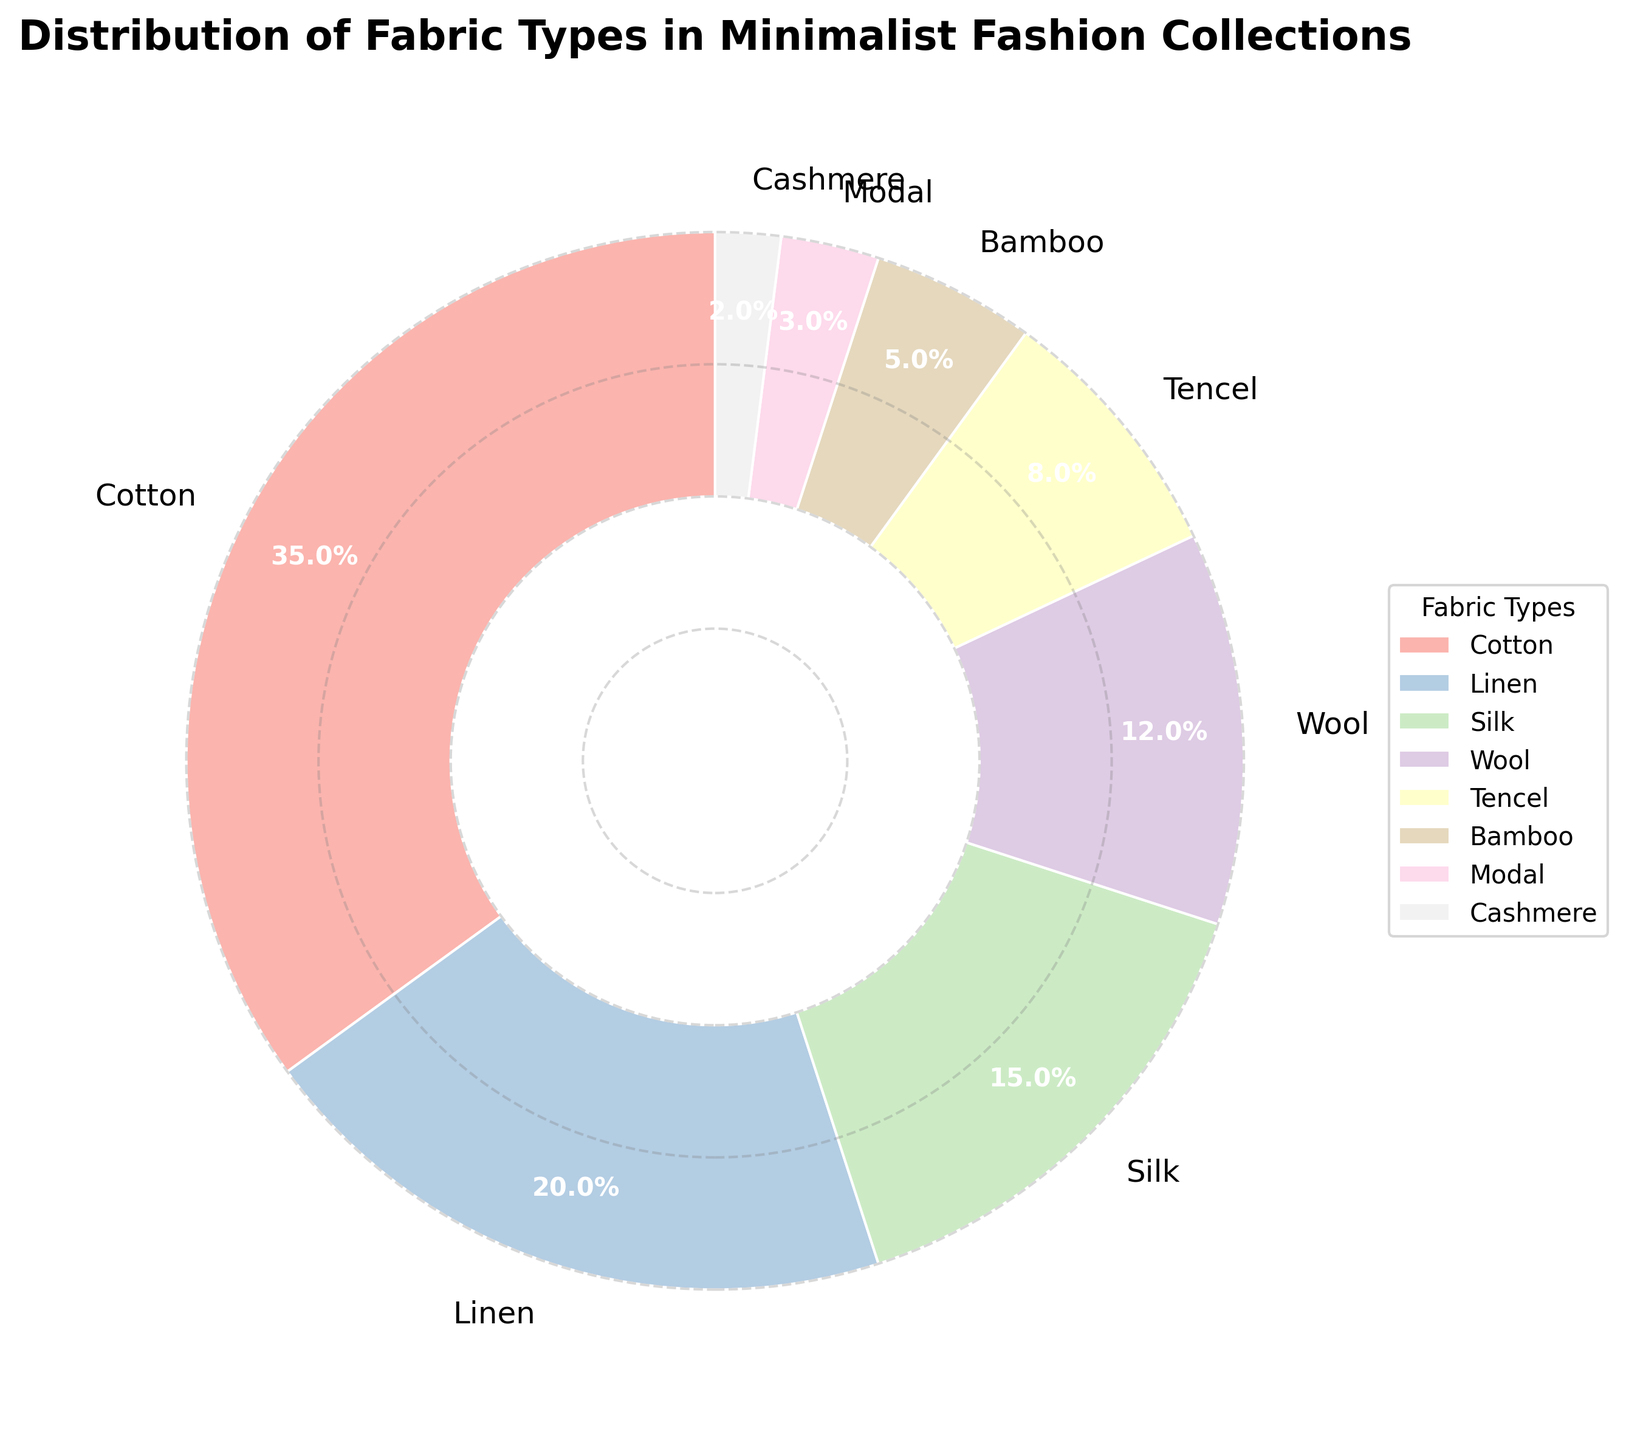Which fabric type has the highest percentage? By looking at the pie chart, the largest wedge represents the fabric with the highest percentage. The section corresponding to Cotton is the largest.
Answer: Cotton Which fabric types together make up more than half of the total percentage? Adding up the percentages starting from the largest, we get Cotton (35%) + Linen (20%) which equals 55%, already exceeding 50%. Hence, Cotton and Linen together make up more than half of the total percentage.
Answer: Cotton and Linen What is the combined percentage of Silk and Wool? By adding the individual percentages of Silk (15%) and Wool (12%), the combined percentage is 15% + 12% = 27%.
Answer: 27% Which fabric type has the smallest percentage? Looking at the pie chart, we identify the smallest wedge, which corresponds to Cashmere with a percentage of 2%.
Answer: Cashmere How do the percentages of Tencel and Bamboo compare? Comparing the sizes of the pie sections for Tencel and Bamboo, Tencel's section is larger. The percentages are Tencel (8%) and Bamboo (5%), so Tencel has a higher percentage than Bamboo.
Answer: Tencel has a higher percentage than Bamboo What is the total percentage of the fabric types with less than 10%? Adding the percentages of Tencel (8%), Bamboo (5%), Modal (3%), and Cashmere (2%), the total percentage is 8% + 5% + 3% + 2% = 18%.
Answer: 18% How does the sum of percentages of Cotton and Silk compare to 50%? The sum of the percentages of Cotton (35%) and Silk (15%) is 35% + 15% = 50%, which is exactly 50%.
Answer: Equal to 50% What is the average percentage of Linen, Wool, and Bamboo? Adding the percentages of Linen (20%), Wool (12%), and Bamboo (5%), we get a total of 20% + 12% + 5% = 37%. Dividing by 3 gives us the average: 37% / 3 = 12.33%.
Answer: 12.33% Between Modal and Cashmere, which fabric type is used more? Comparing the sizes of the pie sections for Modal and Cashmere, the section for Modal is larger. Modal has 3% and Cashmere has 2%, so Modal is used more.
Answer: Modal What fraction of the pie chart is made up of Bamboo and Modal combined? We add the percentages of Bamboo (5%) and Modal (3%) to get 8%. As a fraction of the total pie, this is 8%/100% = 8/100 = 4/50 = 2/25.
Answer: 2/25 